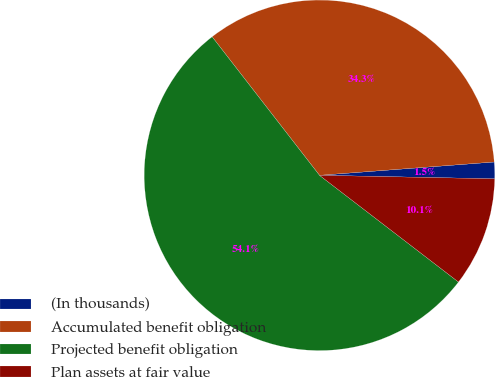<chart> <loc_0><loc_0><loc_500><loc_500><pie_chart><fcel>(In thousands)<fcel>Accumulated benefit obligation<fcel>Projected benefit obligation<fcel>Plan assets at fair value<nl><fcel>1.53%<fcel>34.28%<fcel>54.08%<fcel>10.1%<nl></chart> 